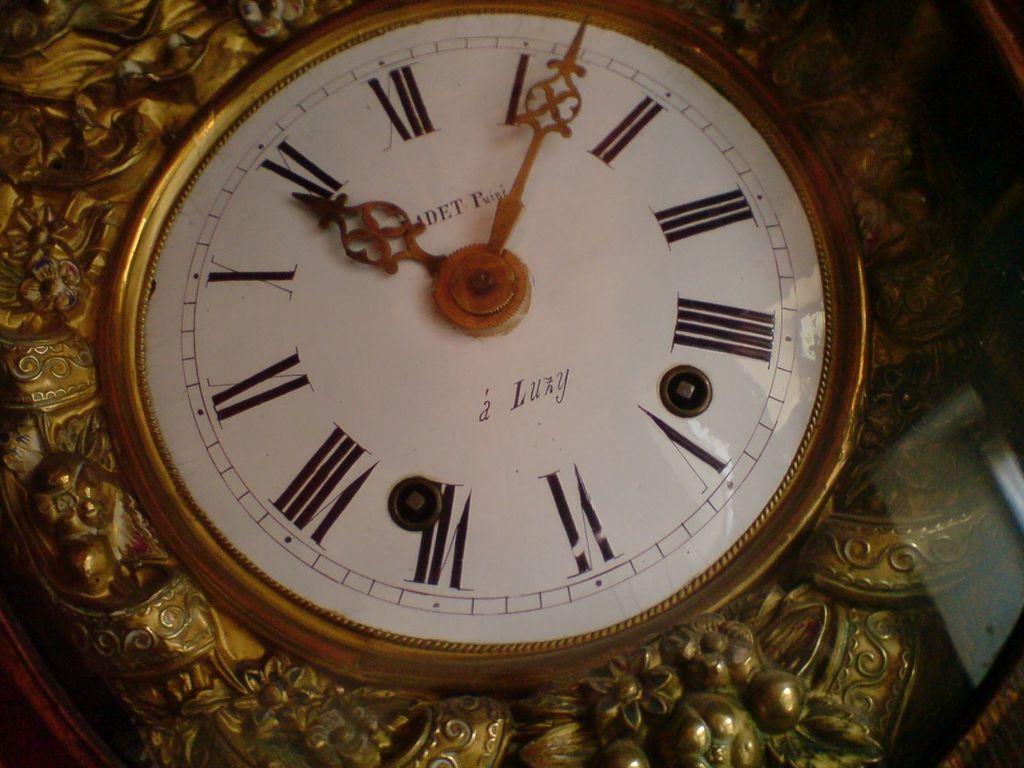What time is it according to this clock?
Make the answer very short. 11:05. 